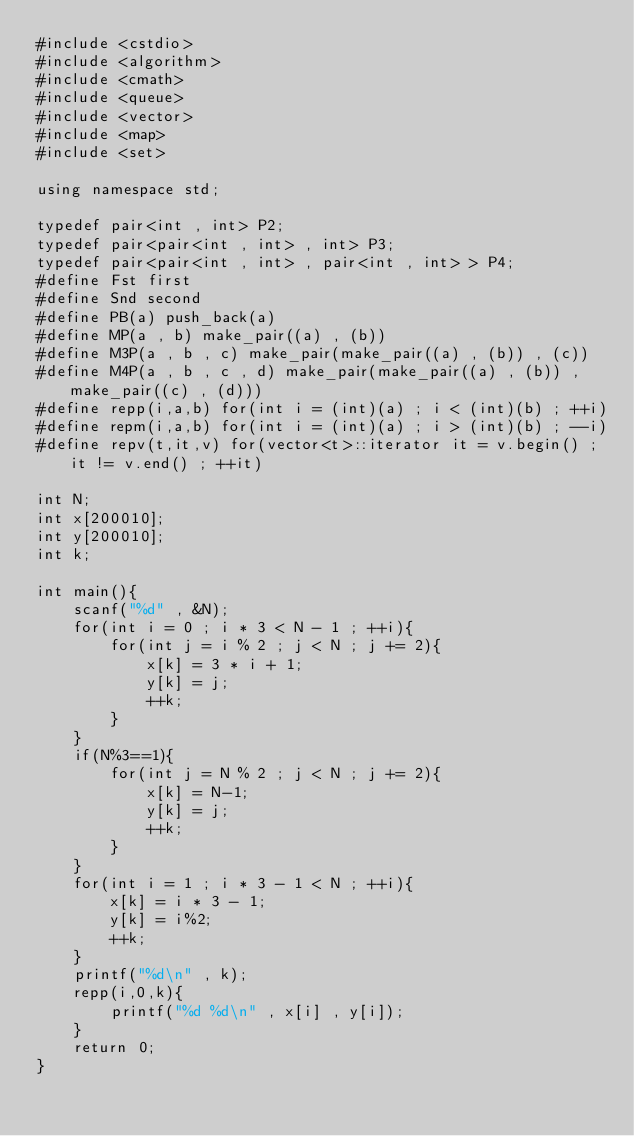<code> <loc_0><loc_0><loc_500><loc_500><_C++_>#include <cstdio>
#include <algorithm>
#include <cmath>
#include <queue>
#include <vector>
#include <map>
#include <set>

using namespace std;

typedef pair<int , int> P2;
typedef pair<pair<int , int> , int> P3;
typedef pair<pair<int , int> , pair<int , int> > P4;
#define Fst first
#define Snd second
#define PB(a) push_back(a)
#define MP(a , b) make_pair((a) , (b))
#define M3P(a , b , c) make_pair(make_pair((a) , (b)) , (c))
#define M4P(a , b , c , d) make_pair(make_pair((a) , (b)) , make_pair((c) , (d)))
#define repp(i,a,b) for(int i = (int)(a) ; i < (int)(b) ; ++i)
#define repm(i,a,b) for(int i = (int)(a) ; i > (int)(b) ; --i)
#define repv(t,it,v) for(vector<t>::iterator it = v.begin() ; it != v.end() ; ++it)

int N;
int x[200010];
int y[200010];
int k;

int main(){
	scanf("%d" , &N);
	for(int i = 0 ; i * 3 < N - 1 ; ++i){
		for(int j = i % 2 ; j < N ; j += 2){
			x[k] = 3 * i + 1;
			y[k] = j;
			++k;
		}
	}
	if(N%3==1){
		for(int j = N % 2 ; j < N ; j += 2){
			x[k] = N-1;
			y[k] = j;
			++k;
		}
	}
	for(int i = 1 ; i * 3 - 1 < N ; ++i){
		x[k] = i * 3 - 1;
		y[k] = i%2;
		++k;
	}
	printf("%d\n" , k);
	repp(i,0,k){
		printf("%d %d\n" , x[i] , y[i]);
	}
	return 0;
}
</code> 